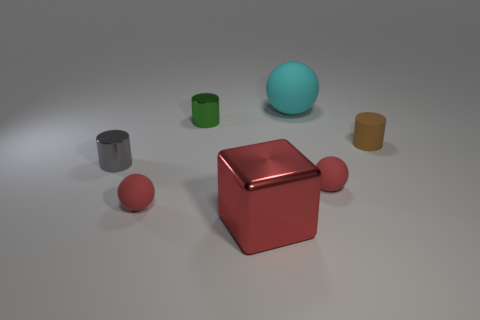Do the gray thing and the green object have the same size?
Your answer should be very brief. Yes. How many other rubber things have the same shape as the large cyan rubber object?
Make the answer very short. 2. What is the color of the cube that is the same size as the cyan ball?
Your answer should be very brief. Red. Are there an equal number of small gray objects in front of the big cube and metallic cylinders that are behind the tiny gray cylinder?
Offer a terse response. No. Is there a green object that has the same size as the metal cube?
Provide a short and direct response. No. How big is the cyan matte sphere?
Offer a terse response. Large. Is the number of cyan rubber balls left of the big red object the same as the number of green spheres?
Offer a terse response. Yes. What number of other things are the same color as the big block?
Offer a very short reply. 2. What color is the rubber sphere that is both on the right side of the big red object and in front of the cyan thing?
Your answer should be very brief. Red. How big is the thing behind the metal cylinder behind the cylinder in front of the brown rubber cylinder?
Your answer should be very brief. Large. 